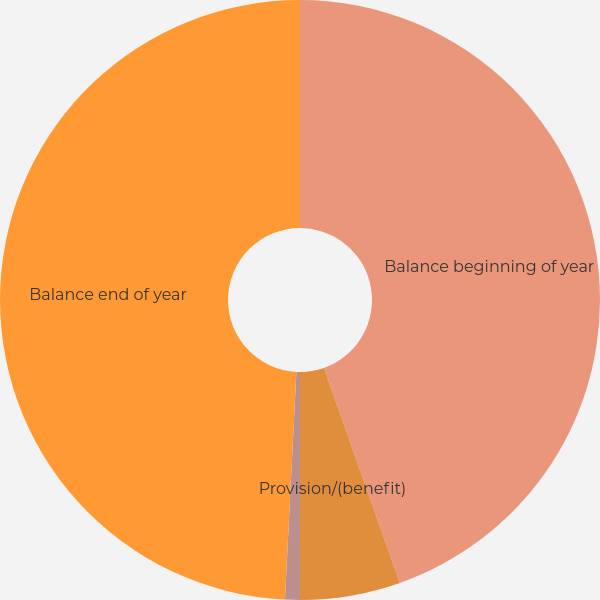<chart> <loc_0><loc_0><loc_500><loc_500><pie_chart><fcel>Balance beginning of year<fcel>Provision/(benefit)<fcel>Other additions/(deductions)<fcel>Balance end of year<nl><fcel>44.6%<fcel>5.4%<fcel>0.8%<fcel>49.2%<nl></chart> 